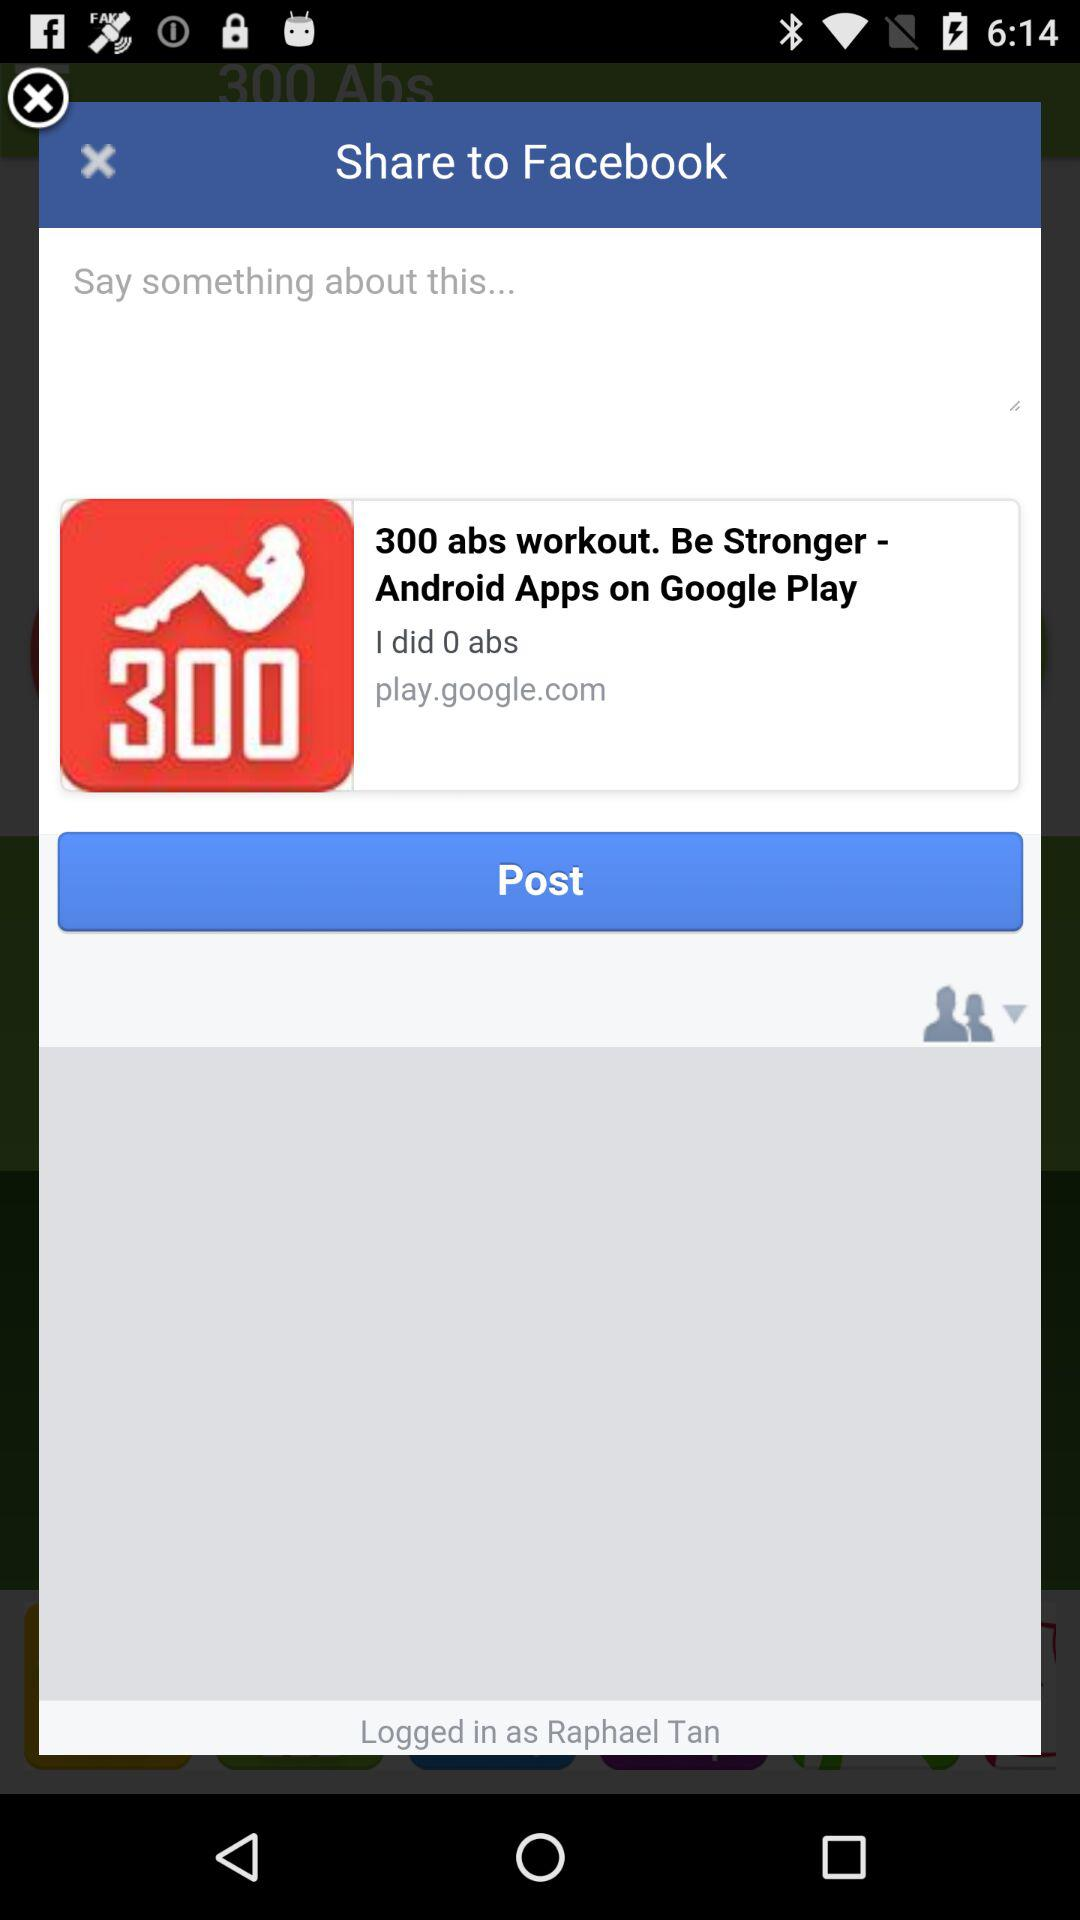How many more abs do I need to do?
Answer the question using a single word or phrase. 300 